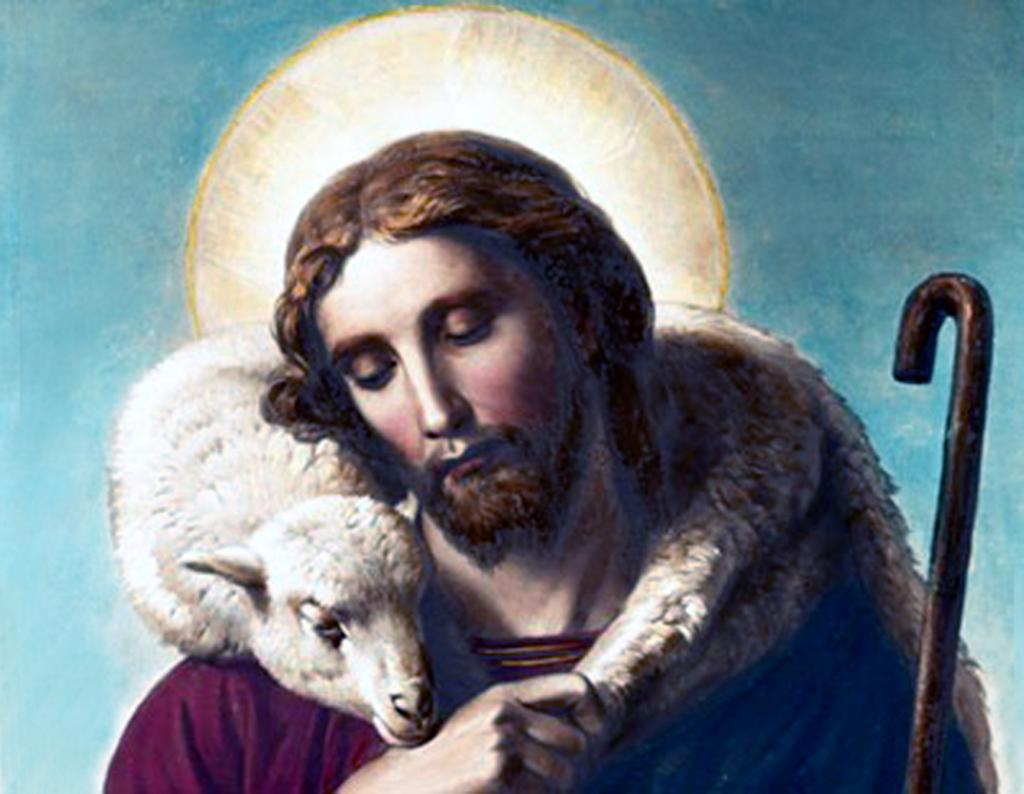What colors can be seen in the background of the image? The background of the picture has blue, yellow, and cream colors. Who is present in the image? There is a man in the image. What is the man doing in the image? The man is carrying a sheep on his shoulders. What object can be seen in the image that might be used for support or assistance? There is a cane or walking stick in the image. What type of education is the man receiving in the image? There is no indication in the image that the man is receiving any education. What color is the silver object in the image? There is no silver object present in the image. 